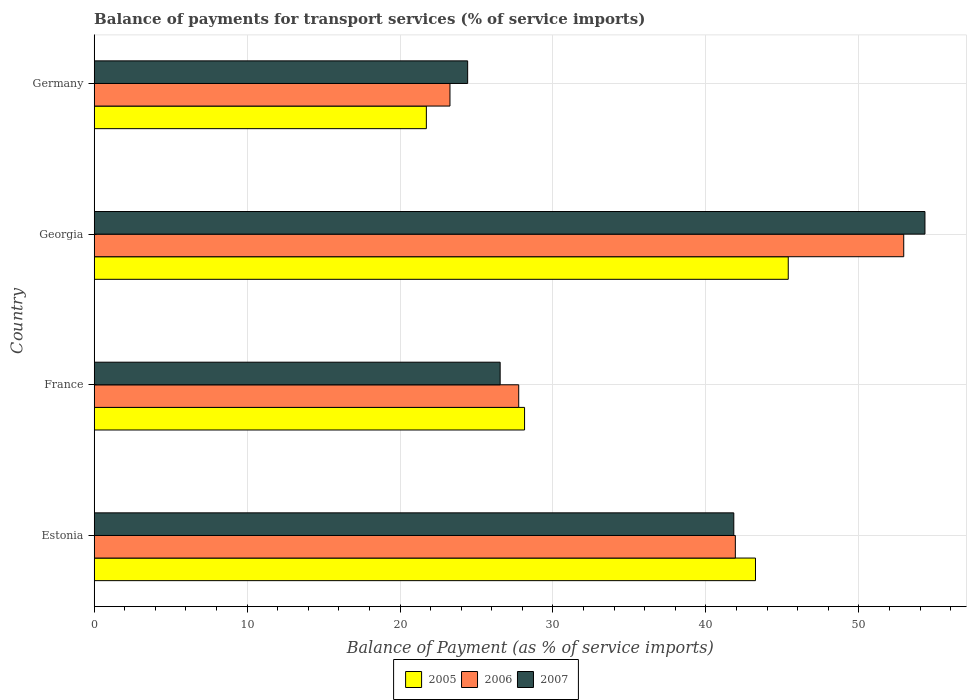How many different coloured bars are there?
Your response must be concise. 3. How many bars are there on the 4th tick from the top?
Make the answer very short. 3. How many bars are there on the 1st tick from the bottom?
Ensure brevity in your answer.  3. What is the label of the 2nd group of bars from the top?
Make the answer very short. Georgia. In how many cases, is the number of bars for a given country not equal to the number of legend labels?
Make the answer very short. 0. What is the balance of payments for transport services in 2006 in France?
Provide a succinct answer. 27.76. Across all countries, what is the maximum balance of payments for transport services in 2007?
Make the answer very short. 54.32. Across all countries, what is the minimum balance of payments for transport services in 2006?
Your answer should be very brief. 23.26. In which country was the balance of payments for transport services in 2005 maximum?
Provide a short and direct response. Georgia. In which country was the balance of payments for transport services in 2007 minimum?
Ensure brevity in your answer.  Germany. What is the total balance of payments for transport services in 2006 in the graph?
Provide a succinct answer. 145.88. What is the difference between the balance of payments for transport services in 2006 in Estonia and that in Georgia?
Your answer should be compact. -11.01. What is the difference between the balance of payments for transport services in 2005 in Germany and the balance of payments for transport services in 2006 in Georgia?
Give a very brief answer. -31.22. What is the average balance of payments for transport services in 2007 per country?
Keep it short and to the point. 36.78. What is the difference between the balance of payments for transport services in 2006 and balance of payments for transport services in 2005 in Germany?
Your answer should be very brief. 1.54. In how many countries, is the balance of payments for transport services in 2007 greater than 22 %?
Offer a terse response. 4. What is the ratio of the balance of payments for transport services in 2005 in Estonia to that in France?
Provide a short and direct response. 1.54. What is the difference between the highest and the second highest balance of payments for transport services in 2007?
Your response must be concise. 12.5. What is the difference between the highest and the lowest balance of payments for transport services in 2007?
Your answer should be very brief. 29.9. What does the 3rd bar from the top in France represents?
Offer a terse response. 2005. What does the 3rd bar from the bottom in Georgia represents?
Offer a terse response. 2007. How many countries are there in the graph?
Offer a very short reply. 4. What is the difference between two consecutive major ticks on the X-axis?
Your answer should be compact. 10. Where does the legend appear in the graph?
Offer a very short reply. Bottom center. What is the title of the graph?
Make the answer very short. Balance of payments for transport services (% of service imports). Does "1976" appear as one of the legend labels in the graph?
Offer a very short reply. No. What is the label or title of the X-axis?
Your response must be concise. Balance of Payment (as % of service imports). What is the label or title of the Y-axis?
Give a very brief answer. Country. What is the Balance of Payment (as % of service imports) of 2005 in Estonia?
Ensure brevity in your answer.  43.24. What is the Balance of Payment (as % of service imports) of 2006 in Estonia?
Keep it short and to the point. 41.92. What is the Balance of Payment (as % of service imports) in 2007 in Estonia?
Provide a succinct answer. 41.82. What is the Balance of Payment (as % of service imports) in 2005 in France?
Provide a succinct answer. 28.14. What is the Balance of Payment (as % of service imports) in 2006 in France?
Give a very brief answer. 27.76. What is the Balance of Payment (as % of service imports) of 2007 in France?
Ensure brevity in your answer.  26.55. What is the Balance of Payment (as % of service imports) in 2005 in Georgia?
Ensure brevity in your answer.  45.38. What is the Balance of Payment (as % of service imports) of 2006 in Georgia?
Your answer should be compact. 52.94. What is the Balance of Payment (as % of service imports) in 2007 in Georgia?
Ensure brevity in your answer.  54.32. What is the Balance of Payment (as % of service imports) in 2005 in Germany?
Provide a short and direct response. 21.72. What is the Balance of Payment (as % of service imports) in 2006 in Germany?
Your answer should be very brief. 23.26. What is the Balance of Payment (as % of service imports) of 2007 in Germany?
Provide a short and direct response. 24.42. Across all countries, what is the maximum Balance of Payment (as % of service imports) of 2005?
Make the answer very short. 45.38. Across all countries, what is the maximum Balance of Payment (as % of service imports) in 2006?
Give a very brief answer. 52.94. Across all countries, what is the maximum Balance of Payment (as % of service imports) of 2007?
Offer a very short reply. 54.32. Across all countries, what is the minimum Balance of Payment (as % of service imports) of 2005?
Your answer should be compact. 21.72. Across all countries, what is the minimum Balance of Payment (as % of service imports) of 2006?
Provide a succinct answer. 23.26. Across all countries, what is the minimum Balance of Payment (as % of service imports) of 2007?
Give a very brief answer. 24.42. What is the total Balance of Payment (as % of service imports) in 2005 in the graph?
Make the answer very short. 138.49. What is the total Balance of Payment (as % of service imports) in 2006 in the graph?
Make the answer very short. 145.88. What is the total Balance of Payment (as % of service imports) of 2007 in the graph?
Offer a very short reply. 147.11. What is the difference between the Balance of Payment (as % of service imports) of 2005 in Estonia and that in France?
Provide a succinct answer. 15.1. What is the difference between the Balance of Payment (as % of service imports) in 2006 in Estonia and that in France?
Your answer should be very brief. 14.16. What is the difference between the Balance of Payment (as % of service imports) of 2007 in Estonia and that in France?
Make the answer very short. 15.28. What is the difference between the Balance of Payment (as % of service imports) in 2005 in Estonia and that in Georgia?
Offer a very short reply. -2.14. What is the difference between the Balance of Payment (as % of service imports) of 2006 in Estonia and that in Georgia?
Make the answer very short. -11.01. What is the difference between the Balance of Payment (as % of service imports) of 2007 in Estonia and that in Georgia?
Provide a succinct answer. -12.5. What is the difference between the Balance of Payment (as % of service imports) in 2005 in Estonia and that in Germany?
Ensure brevity in your answer.  21.52. What is the difference between the Balance of Payment (as % of service imports) of 2006 in Estonia and that in Germany?
Offer a terse response. 18.66. What is the difference between the Balance of Payment (as % of service imports) of 2007 in Estonia and that in Germany?
Ensure brevity in your answer.  17.4. What is the difference between the Balance of Payment (as % of service imports) in 2005 in France and that in Georgia?
Provide a succinct answer. -17.24. What is the difference between the Balance of Payment (as % of service imports) of 2006 in France and that in Georgia?
Your answer should be compact. -25.18. What is the difference between the Balance of Payment (as % of service imports) of 2007 in France and that in Georgia?
Offer a terse response. -27.78. What is the difference between the Balance of Payment (as % of service imports) in 2005 in France and that in Germany?
Your response must be concise. 6.42. What is the difference between the Balance of Payment (as % of service imports) in 2006 in France and that in Germany?
Provide a succinct answer. 4.5. What is the difference between the Balance of Payment (as % of service imports) of 2007 in France and that in Germany?
Ensure brevity in your answer.  2.12. What is the difference between the Balance of Payment (as % of service imports) in 2005 in Georgia and that in Germany?
Provide a short and direct response. 23.66. What is the difference between the Balance of Payment (as % of service imports) of 2006 in Georgia and that in Germany?
Give a very brief answer. 29.67. What is the difference between the Balance of Payment (as % of service imports) in 2007 in Georgia and that in Germany?
Ensure brevity in your answer.  29.9. What is the difference between the Balance of Payment (as % of service imports) in 2005 in Estonia and the Balance of Payment (as % of service imports) in 2006 in France?
Provide a short and direct response. 15.48. What is the difference between the Balance of Payment (as % of service imports) in 2005 in Estonia and the Balance of Payment (as % of service imports) in 2007 in France?
Offer a terse response. 16.7. What is the difference between the Balance of Payment (as % of service imports) of 2006 in Estonia and the Balance of Payment (as % of service imports) of 2007 in France?
Ensure brevity in your answer.  15.38. What is the difference between the Balance of Payment (as % of service imports) in 2005 in Estonia and the Balance of Payment (as % of service imports) in 2006 in Georgia?
Provide a succinct answer. -9.69. What is the difference between the Balance of Payment (as % of service imports) in 2005 in Estonia and the Balance of Payment (as % of service imports) in 2007 in Georgia?
Provide a short and direct response. -11.08. What is the difference between the Balance of Payment (as % of service imports) of 2006 in Estonia and the Balance of Payment (as % of service imports) of 2007 in Georgia?
Ensure brevity in your answer.  -12.4. What is the difference between the Balance of Payment (as % of service imports) of 2005 in Estonia and the Balance of Payment (as % of service imports) of 2006 in Germany?
Provide a short and direct response. 19.98. What is the difference between the Balance of Payment (as % of service imports) in 2005 in Estonia and the Balance of Payment (as % of service imports) in 2007 in Germany?
Your answer should be compact. 18.82. What is the difference between the Balance of Payment (as % of service imports) in 2006 in Estonia and the Balance of Payment (as % of service imports) in 2007 in Germany?
Your answer should be compact. 17.5. What is the difference between the Balance of Payment (as % of service imports) in 2005 in France and the Balance of Payment (as % of service imports) in 2006 in Georgia?
Offer a very short reply. -24.79. What is the difference between the Balance of Payment (as % of service imports) of 2005 in France and the Balance of Payment (as % of service imports) of 2007 in Georgia?
Keep it short and to the point. -26.18. What is the difference between the Balance of Payment (as % of service imports) in 2006 in France and the Balance of Payment (as % of service imports) in 2007 in Georgia?
Keep it short and to the point. -26.56. What is the difference between the Balance of Payment (as % of service imports) in 2005 in France and the Balance of Payment (as % of service imports) in 2006 in Germany?
Give a very brief answer. 4.88. What is the difference between the Balance of Payment (as % of service imports) in 2005 in France and the Balance of Payment (as % of service imports) in 2007 in Germany?
Your answer should be very brief. 3.72. What is the difference between the Balance of Payment (as % of service imports) of 2006 in France and the Balance of Payment (as % of service imports) of 2007 in Germany?
Your response must be concise. 3.34. What is the difference between the Balance of Payment (as % of service imports) in 2005 in Georgia and the Balance of Payment (as % of service imports) in 2006 in Germany?
Give a very brief answer. 22.12. What is the difference between the Balance of Payment (as % of service imports) in 2005 in Georgia and the Balance of Payment (as % of service imports) in 2007 in Germany?
Your response must be concise. 20.96. What is the difference between the Balance of Payment (as % of service imports) of 2006 in Georgia and the Balance of Payment (as % of service imports) of 2007 in Germany?
Make the answer very short. 28.52. What is the average Balance of Payment (as % of service imports) of 2005 per country?
Your answer should be compact. 34.62. What is the average Balance of Payment (as % of service imports) in 2006 per country?
Provide a short and direct response. 36.47. What is the average Balance of Payment (as % of service imports) of 2007 per country?
Offer a very short reply. 36.78. What is the difference between the Balance of Payment (as % of service imports) in 2005 and Balance of Payment (as % of service imports) in 2006 in Estonia?
Your response must be concise. 1.32. What is the difference between the Balance of Payment (as % of service imports) in 2005 and Balance of Payment (as % of service imports) in 2007 in Estonia?
Give a very brief answer. 1.42. What is the difference between the Balance of Payment (as % of service imports) in 2006 and Balance of Payment (as % of service imports) in 2007 in Estonia?
Provide a succinct answer. 0.1. What is the difference between the Balance of Payment (as % of service imports) in 2005 and Balance of Payment (as % of service imports) in 2006 in France?
Provide a succinct answer. 0.38. What is the difference between the Balance of Payment (as % of service imports) of 2005 and Balance of Payment (as % of service imports) of 2007 in France?
Offer a terse response. 1.6. What is the difference between the Balance of Payment (as % of service imports) of 2006 and Balance of Payment (as % of service imports) of 2007 in France?
Provide a short and direct response. 1.21. What is the difference between the Balance of Payment (as % of service imports) in 2005 and Balance of Payment (as % of service imports) in 2006 in Georgia?
Give a very brief answer. -7.55. What is the difference between the Balance of Payment (as % of service imports) of 2005 and Balance of Payment (as % of service imports) of 2007 in Georgia?
Your answer should be very brief. -8.94. What is the difference between the Balance of Payment (as % of service imports) in 2006 and Balance of Payment (as % of service imports) in 2007 in Georgia?
Provide a succinct answer. -1.39. What is the difference between the Balance of Payment (as % of service imports) in 2005 and Balance of Payment (as % of service imports) in 2006 in Germany?
Your answer should be compact. -1.54. What is the difference between the Balance of Payment (as % of service imports) in 2005 and Balance of Payment (as % of service imports) in 2007 in Germany?
Give a very brief answer. -2.7. What is the difference between the Balance of Payment (as % of service imports) in 2006 and Balance of Payment (as % of service imports) in 2007 in Germany?
Offer a very short reply. -1.16. What is the ratio of the Balance of Payment (as % of service imports) of 2005 in Estonia to that in France?
Provide a short and direct response. 1.54. What is the ratio of the Balance of Payment (as % of service imports) in 2006 in Estonia to that in France?
Keep it short and to the point. 1.51. What is the ratio of the Balance of Payment (as % of service imports) in 2007 in Estonia to that in France?
Provide a succinct answer. 1.58. What is the ratio of the Balance of Payment (as % of service imports) of 2005 in Estonia to that in Georgia?
Provide a short and direct response. 0.95. What is the ratio of the Balance of Payment (as % of service imports) in 2006 in Estonia to that in Georgia?
Provide a short and direct response. 0.79. What is the ratio of the Balance of Payment (as % of service imports) of 2007 in Estonia to that in Georgia?
Offer a terse response. 0.77. What is the ratio of the Balance of Payment (as % of service imports) in 2005 in Estonia to that in Germany?
Keep it short and to the point. 1.99. What is the ratio of the Balance of Payment (as % of service imports) in 2006 in Estonia to that in Germany?
Your response must be concise. 1.8. What is the ratio of the Balance of Payment (as % of service imports) in 2007 in Estonia to that in Germany?
Your answer should be compact. 1.71. What is the ratio of the Balance of Payment (as % of service imports) in 2005 in France to that in Georgia?
Give a very brief answer. 0.62. What is the ratio of the Balance of Payment (as % of service imports) of 2006 in France to that in Georgia?
Your response must be concise. 0.52. What is the ratio of the Balance of Payment (as % of service imports) in 2007 in France to that in Georgia?
Your answer should be compact. 0.49. What is the ratio of the Balance of Payment (as % of service imports) in 2005 in France to that in Germany?
Keep it short and to the point. 1.3. What is the ratio of the Balance of Payment (as % of service imports) of 2006 in France to that in Germany?
Offer a very short reply. 1.19. What is the ratio of the Balance of Payment (as % of service imports) in 2007 in France to that in Germany?
Offer a very short reply. 1.09. What is the ratio of the Balance of Payment (as % of service imports) in 2005 in Georgia to that in Germany?
Provide a succinct answer. 2.09. What is the ratio of the Balance of Payment (as % of service imports) in 2006 in Georgia to that in Germany?
Provide a short and direct response. 2.28. What is the ratio of the Balance of Payment (as % of service imports) of 2007 in Georgia to that in Germany?
Your answer should be very brief. 2.22. What is the difference between the highest and the second highest Balance of Payment (as % of service imports) in 2005?
Make the answer very short. 2.14. What is the difference between the highest and the second highest Balance of Payment (as % of service imports) in 2006?
Your response must be concise. 11.01. What is the difference between the highest and the second highest Balance of Payment (as % of service imports) of 2007?
Provide a short and direct response. 12.5. What is the difference between the highest and the lowest Balance of Payment (as % of service imports) of 2005?
Provide a succinct answer. 23.66. What is the difference between the highest and the lowest Balance of Payment (as % of service imports) of 2006?
Provide a short and direct response. 29.67. What is the difference between the highest and the lowest Balance of Payment (as % of service imports) of 2007?
Provide a succinct answer. 29.9. 